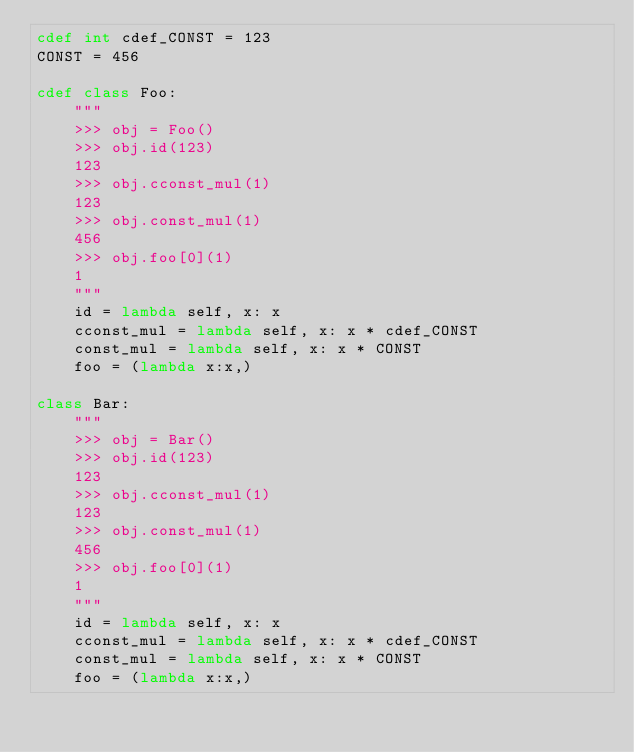<code> <loc_0><loc_0><loc_500><loc_500><_Cython_>cdef int cdef_CONST = 123
CONST = 456

cdef class Foo:
    """
    >>> obj = Foo()
    >>> obj.id(123)
    123
    >>> obj.cconst_mul(1)
    123
    >>> obj.const_mul(1)
    456
    >>> obj.foo[0](1)
    1
    """
    id = lambda self, x: x
    cconst_mul = lambda self, x: x * cdef_CONST
    const_mul = lambda self, x: x * CONST
    foo = (lambda x:x,)

class Bar:
    """
    >>> obj = Bar()
    >>> obj.id(123)
    123
    >>> obj.cconst_mul(1)
    123
    >>> obj.const_mul(1)
    456
    >>> obj.foo[0](1)
    1
    """
    id = lambda self, x: x
    cconst_mul = lambda self, x: x * cdef_CONST
    const_mul = lambda self, x: x * CONST
    foo = (lambda x:x,)
</code> 